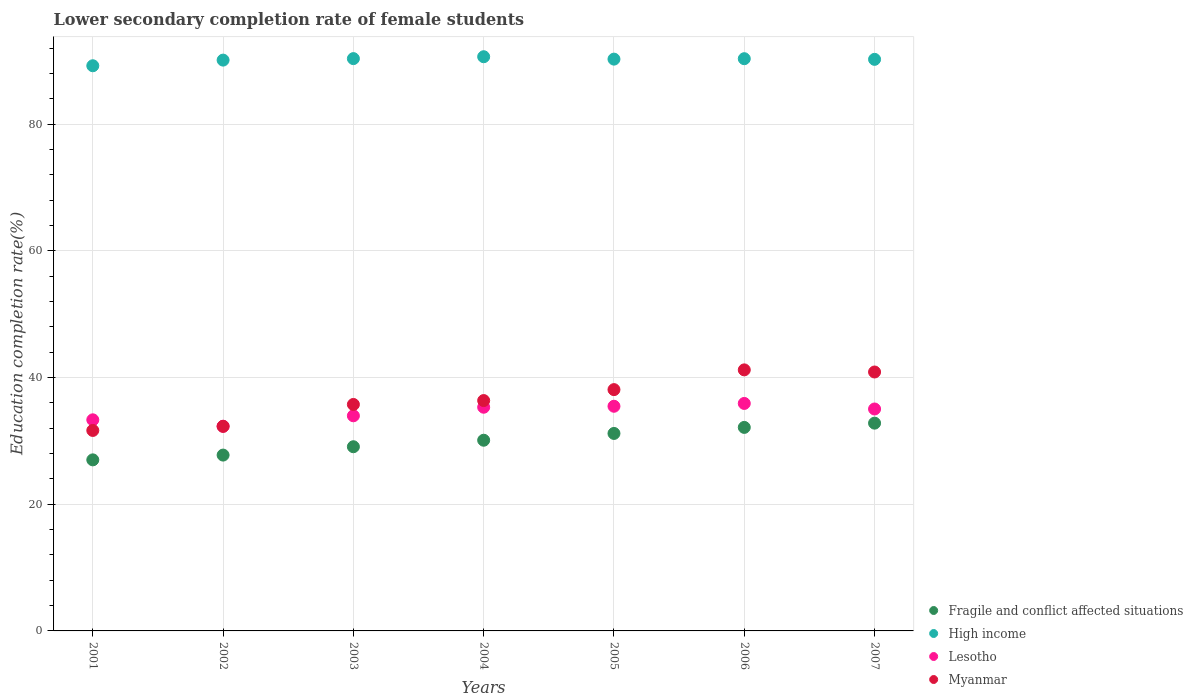How many different coloured dotlines are there?
Your answer should be very brief. 4. Is the number of dotlines equal to the number of legend labels?
Offer a terse response. Yes. What is the lower secondary completion rate of female students in High income in 2002?
Your response must be concise. 90.14. Across all years, what is the maximum lower secondary completion rate of female students in Myanmar?
Offer a very short reply. 41.22. Across all years, what is the minimum lower secondary completion rate of female students in Fragile and conflict affected situations?
Keep it short and to the point. 27.01. In which year was the lower secondary completion rate of female students in Lesotho maximum?
Provide a succinct answer. 2006. What is the total lower secondary completion rate of female students in Myanmar in the graph?
Offer a very short reply. 256.32. What is the difference between the lower secondary completion rate of female students in Fragile and conflict affected situations in 2001 and that in 2002?
Provide a short and direct response. -0.75. What is the difference between the lower secondary completion rate of female students in Fragile and conflict affected situations in 2004 and the lower secondary completion rate of female students in High income in 2005?
Your answer should be compact. -60.18. What is the average lower secondary completion rate of female students in Fragile and conflict affected situations per year?
Your response must be concise. 30.02. In the year 2005, what is the difference between the lower secondary completion rate of female students in High income and lower secondary completion rate of female students in Fragile and conflict affected situations?
Give a very brief answer. 59.11. In how many years, is the lower secondary completion rate of female students in Myanmar greater than 84 %?
Your response must be concise. 0. What is the ratio of the lower secondary completion rate of female students in Lesotho in 2001 to that in 2002?
Ensure brevity in your answer.  1.03. Is the difference between the lower secondary completion rate of female students in High income in 2003 and 2007 greater than the difference between the lower secondary completion rate of female students in Fragile and conflict affected situations in 2003 and 2007?
Make the answer very short. Yes. What is the difference between the highest and the second highest lower secondary completion rate of female students in High income?
Your answer should be compact. 0.3. What is the difference between the highest and the lowest lower secondary completion rate of female students in Myanmar?
Your answer should be very brief. 9.57. Is the sum of the lower secondary completion rate of female students in Myanmar in 2002 and 2003 greater than the maximum lower secondary completion rate of female students in Fragile and conflict affected situations across all years?
Offer a terse response. Yes. Does the lower secondary completion rate of female students in Myanmar monotonically increase over the years?
Provide a short and direct response. No. Is the lower secondary completion rate of female students in High income strictly greater than the lower secondary completion rate of female students in Fragile and conflict affected situations over the years?
Offer a very short reply. Yes. Is the lower secondary completion rate of female students in Myanmar strictly less than the lower secondary completion rate of female students in Fragile and conflict affected situations over the years?
Your answer should be very brief. No. How many dotlines are there?
Offer a very short reply. 4. How many years are there in the graph?
Provide a short and direct response. 7. Are the values on the major ticks of Y-axis written in scientific E-notation?
Make the answer very short. No. Does the graph contain any zero values?
Your response must be concise. No. Does the graph contain grids?
Give a very brief answer. Yes. How many legend labels are there?
Your answer should be very brief. 4. How are the legend labels stacked?
Your answer should be compact. Vertical. What is the title of the graph?
Give a very brief answer. Lower secondary completion rate of female students. Does "Kazakhstan" appear as one of the legend labels in the graph?
Ensure brevity in your answer.  No. What is the label or title of the X-axis?
Your response must be concise. Years. What is the label or title of the Y-axis?
Your answer should be compact. Education completion rate(%). What is the Education completion rate(%) of Fragile and conflict affected situations in 2001?
Make the answer very short. 27.01. What is the Education completion rate(%) in High income in 2001?
Your answer should be compact. 89.25. What is the Education completion rate(%) in Lesotho in 2001?
Your response must be concise. 33.34. What is the Education completion rate(%) in Myanmar in 2001?
Your answer should be compact. 31.66. What is the Education completion rate(%) of Fragile and conflict affected situations in 2002?
Provide a short and direct response. 27.77. What is the Education completion rate(%) of High income in 2002?
Your answer should be compact. 90.14. What is the Education completion rate(%) in Lesotho in 2002?
Your answer should be compact. 32.33. What is the Education completion rate(%) of Myanmar in 2002?
Your answer should be very brief. 32.3. What is the Education completion rate(%) of Fragile and conflict affected situations in 2003?
Your response must be concise. 29.09. What is the Education completion rate(%) in High income in 2003?
Your answer should be compact. 90.38. What is the Education completion rate(%) in Lesotho in 2003?
Provide a short and direct response. 33.97. What is the Education completion rate(%) in Myanmar in 2003?
Keep it short and to the point. 35.76. What is the Education completion rate(%) of Fragile and conflict affected situations in 2004?
Give a very brief answer. 30.11. What is the Education completion rate(%) of High income in 2004?
Keep it short and to the point. 90.67. What is the Education completion rate(%) of Lesotho in 2004?
Offer a very short reply. 35.32. What is the Education completion rate(%) in Myanmar in 2004?
Offer a very short reply. 36.38. What is the Education completion rate(%) of Fragile and conflict affected situations in 2005?
Give a very brief answer. 31.19. What is the Education completion rate(%) in High income in 2005?
Make the answer very short. 90.3. What is the Education completion rate(%) of Lesotho in 2005?
Your answer should be compact. 35.48. What is the Education completion rate(%) in Myanmar in 2005?
Your answer should be compact. 38.11. What is the Education completion rate(%) in Fragile and conflict affected situations in 2006?
Provide a short and direct response. 32.14. What is the Education completion rate(%) in High income in 2006?
Give a very brief answer. 90.36. What is the Education completion rate(%) in Lesotho in 2006?
Give a very brief answer. 35.92. What is the Education completion rate(%) of Myanmar in 2006?
Give a very brief answer. 41.22. What is the Education completion rate(%) of Fragile and conflict affected situations in 2007?
Ensure brevity in your answer.  32.81. What is the Education completion rate(%) of High income in 2007?
Your response must be concise. 90.26. What is the Education completion rate(%) of Lesotho in 2007?
Offer a very short reply. 35.05. What is the Education completion rate(%) of Myanmar in 2007?
Offer a terse response. 40.89. Across all years, what is the maximum Education completion rate(%) in Fragile and conflict affected situations?
Give a very brief answer. 32.81. Across all years, what is the maximum Education completion rate(%) of High income?
Offer a terse response. 90.67. Across all years, what is the maximum Education completion rate(%) in Lesotho?
Provide a succinct answer. 35.92. Across all years, what is the maximum Education completion rate(%) in Myanmar?
Keep it short and to the point. 41.22. Across all years, what is the minimum Education completion rate(%) of Fragile and conflict affected situations?
Your response must be concise. 27.01. Across all years, what is the minimum Education completion rate(%) in High income?
Keep it short and to the point. 89.25. Across all years, what is the minimum Education completion rate(%) in Lesotho?
Provide a succinct answer. 32.33. Across all years, what is the minimum Education completion rate(%) of Myanmar?
Ensure brevity in your answer.  31.66. What is the total Education completion rate(%) of Fragile and conflict affected situations in the graph?
Offer a terse response. 210.11. What is the total Education completion rate(%) of High income in the graph?
Keep it short and to the point. 631.36. What is the total Education completion rate(%) in Lesotho in the graph?
Give a very brief answer. 241.41. What is the total Education completion rate(%) in Myanmar in the graph?
Your response must be concise. 256.32. What is the difference between the Education completion rate(%) in Fragile and conflict affected situations in 2001 and that in 2002?
Provide a short and direct response. -0.75. What is the difference between the Education completion rate(%) in High income in 2001 and that in 2002?
Offer a very short reply. -0.89. What is the difference between the Education completion rate(%) of Lesotho in 2001 and that in 2002?
Offer a terse response. 1.01. What is the difference between the Education completion rate(%) of Myanmar in 2001 and that in 2002?
Offer a very short reply. -0.65. What is the difference between the Education completion rate(%) of Fragile and conflict affected situations in 2001 and that in 2003?
Offer a terse response. -2.07. What is the difference between the Education completion rate(%) in High income in 2001 and that in 2003?
Give a very brief answer. -1.13. What is the difference between the Education completion rate(%) of Lesotho in 2001 and that in 2003?
Offer a very short reply. -0.63. What is the difference between the Education completion rate(%) in Myanmar in 2001 and that in 2003?
Your response must be concise. -4.11. What is the difference between the Education completion rate(%) of Fragile and conflict affected situations in 2001 and that in 2004?
Make the answer very short. -3.1. What is the difference between the Education completion rate(%) of High income in 2001 and that in 2004?
Give a very brief answer. -1.43. What is the difference between the Education completion rate(%) in Lesotho in 2001 and that in 2004?
Provide a short and direct response. -1.99. What is the difference between the Education completion rate(%) of Myanmar in 2001 and that in 2004?
Offer a terse response. -4.72. What is the difference between the Education completion rate(%) of Fragile and conflict affected situations in 2001 and that in 2005?
Offer a very short reply. -4.17. What is the difference between the Education completion rate(%) in High income in 2001 and that in 2005?
Ensure brevity in your answer.  -1.05. What is the difference between the Education completion rate(%) of Lesotho in 2001 and that in 2005?
Give a very brief answer. -2.14. What is the difference between the Education completion rate(%) of Myanmar in 2001 and that in 2005?
Provide a succinct answer. -6.45. What is the difference between the Education completion rate(%) of Fragile and conflict affected situations in 2001 and that in 2006?
Provide a short and direct response. -5.13. What is the difference between the Education completion rate(%) in High income in 2001 and that in 2006?
Provide a succinct answer. -1.11. What is the difference between the Education completion rate(%) in Lesotho in 2001 and that in 2006?
Keep it short and to the point. -2.59. What is the difference between the Education completion rate(%) in Myanmar in 2001 and that in 2006?
Provide a short and direct response. -9.57. What is the difference between the Education completion rate(%) in Fragile and conflict affected situations in 2001 and that in 2007?
Keep it short and to the point. -5.8. What is the difference between the Education completion rate(%) in High income in 2001 and that in 2007?
Your response must be concise. -1.01. What is the difference between the Education completion rate(%) in Lesotho in 2001 and that in 2007?
Your response must be concise. -1.71. What is the difference between the Education completion rate(%) of Myanmar in 2001 and that in 2007?
Ensure brevity in your answer.  -9.23. What is the difference between the Education completion rate(%) in Fragile and conflict affected situations in 2002 and that in 2003?
Keep it short and to the point. -1.32. What is the difference between the Education completion rate(%) in High income in 2002 and that in 2003?
Offer a terse response. -0.24. What is the difference between the Education completion rate(%) in Lesotho in 2002 and that in 2003?
Provide a succinct answer. -1.64. What is the difference between the Education completion rate(%) of Myanmar in 2002 and that in 2003?
Provide a succinct answer. -3.46. What is the difference between the Education completion rate(%) in Fragile and conflict affected situations in 2002 and that in 2004?
Your response must be concise. -2.35. What is the difference between the Education completion rate(%) of High income in 2002 and that in 2004?
Give a very brief answer. -0.53. What is the difference between the Education completion rate(%) of Lesotho in 2002 and that in 2004?
Offer a very short reply. -3. What is the difference between the Education completion rate(%) of Myanmar in 2002 and that in 2004?
Offer a very short reply. -4.07. What is the difference between the Education completion rate(%) of Fragile and conflict affected situations in 2002 and that in 2005?
Offer a terse response. -3.42. What is the difference between the Education completion rate(%) of High income in 2002 and that in 2005?
Offer a terse response. -0.16. What is the difference between the Education completion rate(%) in Lesotho in 2002 and that in 2005?
Offer a very short reply. -3.15. What is the difference between the Education completion rate(%) of Myanmar in 2002 and that in 2005?
Make the answer very short. -5.8. What is the difference between the Education completion rate(%) of Fragile and conflict affected situations in 2002 and that in 2006?
Make the answer very short. -4.37. What is the difference between the Education completion rate(%) in High income in 2002 and that in 2006?
Your response must be concise. -0.22. What is the difference between the Education completion rate(%) in Lesotho in 2002 and that in 2006?
Ensure brevity in your answer.  -3.6. What is the difference between the Education completion rate(%) of Myanmar in 2002 and that in 2006?
Provide a short and direct response. -8.92. What is the difference between the Education completion rate(%) of Fragile and conflict affected situations in 2002 and that in 2007?
Your response must be concise. -5.04. What is the difference between the Education completion rate(%) of High income in 2002 and that in 2007?
Your response must be concise. -0.12. What is the difference between the Education completion rate(%) of Lesotho in 2002 and that in 2007?
Keep it short and to the point. -2.72. What is the difference between the Education completion rate(%) of Myanmar in 2002 and that in 2007?
Your answer should be very brief. -8.58. What is the difference between the Education completion rate(%) in Fragile and conflict affected situations in 2003 and that in 2004?
Provide a short and direct response. -1.03. What is the difference between the Education completion rate(%) in High income in 2003 and that in 2004?
Provide a short and direct response. -0.3. What is the difference between the Education completion rate(%) of Lesotho in 2003 and that in 2004?
Your answer should be compact. -1.35. What is the difference between the Education completion rate(%) of Myanmar in 2003 and that in 2004?
Your response must be concise. -0.61. What is the difference between the Education completion rate(%) of Fragile and conflict affected situations in 2003 and that in 2005?
Make the answer very short. -2.1. What is the difference between the Education completion rate(%) in High income in 2003 and that in 2005?
Offer a very short reply. 0.08. What is the difference between the Education completion rate(%) in Lesotho in 2003 and that in 2005?
Your answer should be compact. -1.51. What is the difference between the Education completion rate(%) in Myanmar in 2003 and that in 2005?
Offer a terse response. -2.34. What is the difference between the Education completion rate(%) in Fragile and conflict affected situations in 2003 and that in 2006?
Offer a very short reply. -3.05. What is the difference between the Education completion rate(%) in High income in 2003 and that in 2006?
Keep it short and to the point. 0.01. What is the difference between the Education completion rate(%) of Lesotho in 2003 and that in 2006?
Provide a short and direct response. -1.95. What is the difference between the Education completion rate(%) of Myanmar in 2003 and that in 2006?
Provide a succinct answer. -5.46. What is the difference between the Education completion rate(%) of Fragile and conflict affected situations in 2003 and that in 2007?
Offer a terse response. -3.72. What is the difference between the Education completion rate(%) of High income in 2003 and that in 2007?
Offer a terse response. 0.12. What is the difference between the Education completion rate(%) in Lesotho in 2003 and that in 2007?
Your answer should be very brief. -1.07. What is the difference between the Education completion rate(%) of Myanmar in 2003 and that in 2007?
Make the answer very short. -5.12. What is the difference between the Education completion rate(%) of Fragile and conflict affected situations in 2004 and that in 2005?
Ensure brevity in your answer.  -1.07. What is the difference between the Education completion rate(%) in High income in 2004 and that in 2005?
Offer a very short reply. 0.38. What is the difference between the Education completion rate(%) in Lesotho in 2004 and that in 2005?
Your answer should be very brief. -0.15. What is the difference between the Education completion rate(%) in Myanmar in 2004 and that in 2005?
Offer a terse response. -1.73. What is the difference between the Education completion rate(%) in Fragile and conflict affected situations in 2004 and that in 2006?
Provide a succinct answer. -2.03. What is the difference between the Education completion rate(%) of High income in 2004 and that in 2006?
Your answer should be compact. 0.31. What is the difference between the Education completion rate(%) of Lesotho in 2004 and that in 2006?
Provide a succinct answer. -0.6. What is the difference between the Education completion rate(%) in Myanmar in 2004 and that in 2006?
Provide a succinct answer. -4.85. What is the difference between the Education completion rate(%) of Fragile and conflict affected situations in 2004 and that in 2007?
Give a very brief answer. -2.7. What is the difference between the Education completion rate(%) in High income in 2004 and that in 2007?
Keep it short and to the point. 0.41. What is the difference between the Education completion rate(%) in Lesotho in 2004 and that in 2007?
Provide a succinct answer. 0.28. What is the difference between the Education completion rate(%) in Myanmar in 2004 and that in 2007?
Your answer should be compact. -4.51. What is the difference between the Education completion rate(%) in Fragile and conflict affected situations in 2005 and that in 2006?
Ensure brevity in your answer.  -0.95. What is the difference between the Education completion rate(%) in High income in 2005 and that in 2006?
Make the answer very short. -0.07. What is the difference between the Education completion rate(%) of Lesotho in 2005 and that in 2006?
Provide a succinct answer. -0.45. What is the difference between the Education completion rate(%) in Myanmar in 2005 and that in 2006?
Offer a terse response. -3.12. What is the difference between the Education completion rate(%) in Fragile and conflict affected situations in 2005 and that in 2007?
Ensure brevity in your answer.  -1.62. What is the difference between the Education completion rate(%) of High income in 2005 and that in 2007?
Your answer should be very brief. 0.03. What is the difference between the Education completion rate(%) of Lesotho in 2005 and that in 2007?
Your answer should be compact. 0.43. What is the difference between the Education completion rate(%) of Myanmar in 2005 and that in 2007?
Give a very brief answer. -2.78. What is the difference between the Education completion rate(%) of Fragile and conflict affected situations in 2006 and that in 2007?
Your response must be concise. -0.67. What is the difference between the Education completion rate(%) of High income in 2006 and that in 2007?
Offer a very short reply. 0.1. What is the difference between the Education completion rate(%) of Lesotho in 2006 and that in 2007?
Your response must be concise. 0.88. What is the difference between the Education completion rate(%) of Myanmar in 2006 and that in 2007?
Keep it short and to the point. 0.34. What is the difference between the Education completion rate(%) in Fragile and conflict affected situations in 2001 and the Education completion rate(%) in High income in 2002?
Give a very brief answer. -63.13. What is the difference between the Education completion rate(%) in Fragile and conflict affected situations in 2001 and the Education completion rate(%) in Lesotho in 2002?
Your answer should be very brief. -5.31. What is the difference between the Education completion rate(%) of Fragile and conflict affected situations in 2001 and the Education completion rate(%) of Myanmar in 2002?
Give a very brief answer. -5.29. What is the difference between the Education completion rate(%) in High income in 2001 and the Education completion rate(%) in Lesotho in 2002?
Ensure brevity in your answer.  56.92. What is the difference between the Education completion rate(%) of High income in 2001 and the Education completion rate(%) of Myanmar in 2002?
Make the answer very short. 56.95. What is the difference between the Education completion rate(%) in Lesotho in 2001 and the Education completion rate(%) in Myanmar in 2002?
Keep it short and to the point. 1.03. What is the difference between the Education completion rate(%) of Fragile and conflict affected situations in 2001 and the Education completion rate(%) of High income in 2003?
Offer a terse response. -63.36. What is the difference between the Education completion rate(%) in Fragile and conflict affected situations in 2001 and the Education completion rate(%) in Lesotho in 2003?
Offer a terse response. -6.96. What is the difference between the Education completion rate(%) in Fragile and conflict affected situations in 2001 and the Education completion rate(%) in Myanmar in 2003?
Make the answer very short. -8.75. What is the difference between the Education completion rate(%) in High income in 2001 and the Education completion rate(%) in Lesotho in 2003?
Make the answer very short. 55.28. What is the difference between the Education completion rate(%) in High income in 2001 and the Education completion rate(%) in Myanmar in 2003?
Offer a terse response. 53.49. What is the difference between the Education completion rate(%) in Lesotho in 2001 and the Education completion rate(%) in Myanmar in 2003?
Your answer should be compact. -2.43. What is the difference between the Education completion rate(%) in Fragile and conflict affected situations in 2001 and the Education completion rate(%) in High income in 2004?
Provide a succinct answer. -63.66. What is the difference between the Education completion rate(%) in Fragile and conflict affected situations in 2001 and the Education completion rate(%) in Lesotho in 2004?
Keep it short and to the point. -8.31. What is the difference between the Education completion rate(%) in Fragile and conflict affected situations in 2001 and the Education completion rate(%) in Myanmar in 2004?
Make the answer very short. -9.36. What is the difference between the Education completion rate(%) of High income in 2001 and the Education completion rate(%) of Lesotho in 2004?
Your answer should be compact. 53.93. What is the difference between the Education completion rate(%) in High income in 2001 and the Education completion rate(%) in Myanmar in 2004?
Make the answer very short. 52.87. What is the difference between the Education completion rate(%) in Lesotho in 2001 and the Education completion rate(%) in Myanmar in 2004?
Provide a succinct answer. -3.04. What is the difference between the Education completion rate(%) of Fragile and conflict affected situations in 2001 and the Education completion rate(%) of High income in 2005?
Give a very brief answer. -63.28. What is the difference between the Education completion rate(%) in Fragile and conflict affected situations in 2001 and the Education completion rate(%) in Lesotho in 2005?
Provide a short and direct response. -8.46. What is the difference between the Education completion rate(%) of Fragile and conflict affected situations in 2001 and the Education completion rate(%) of Myanmar in 2005?
Provide a succinct answer. -11.09. What is the difference between the Education completion rate(%) of High income in 2001 and the Education completion rate(%) of Lesotho in 2005?
Offer a very short reply. 53.77. What is the difference between the Education completion rate(%) in High income in 2001 and the Education completion rate(%) in Myanmar in 2005?
Make the answer very short. 51.14. What is the difference between the Education completion rate(%) in Lesotho in 2001 and the Education completion rate(%) in Myanmar in 2005?
Ensure brevity in your answer.  -4.77. What is the difference between the Education completion rate(%) of Fragile and conflict affected situations in 2001 and the Education completion rate(%) of High income in 2006?
Ensure brevity in your answer.  -63.35. What is the difference between the Education completion rate(%) in Fragile and conflict affected situations in 2001 and the Education completion rate(%) in Lesotho in 2006?
Offer a terse response. -8.91. What is the difference between the Education completion rate(%) of Fragile and conflict affected situations in 2001 and the Education completion rate(%) of Myanmar in 2006?
Give a very brief answer. -14.21. What is the difference between the Education completion rate(%) of High income in 2001 and the Education completion rate(%) of Lesotho in 2006?
Ensure brevity in your answer.  53.33. What is the difference between the Education completion rate(%) in High income in 2001 and the Education completion rate(%) in Myanmar in 2006?
Give a very brief answer. 48.03. What is the difference between the Education completion rate(%) in Lesotho in 2001 and the Education completion rate(%) in Myanmar in 2006?
Your answer should be very brief. -7.89. What is the difference between the Education completion rate(%) of Fragile and conflict affected situations in 2001 and the Education completion rate(%) of High income in 2007?
Your answer should be very brief. -63.25. What is the difference between the Education completion rate(%) in Fragile and conflict affected situations in 2001 and the Education completion rate(%) in Lesotho in 2007?
Ensure brevity in your answer.  -8.03. What is the difference between the Education completion rate(%) of Fragile and conflict affected situations in 2001 and the Education completion rate(%) of Myanmar in 2007?
Your answer should be compact. -13.87. What is the difference between the Education completion rate(%) of High income in 2001 and the Education completion rate(%) of Lesotho in 2007?
Offer a very short reply. 54.2. What is the difference between the Education completion rate(%) of High income in 2001 and the Education completion rate(%) of Myanmar in 2007?
Your answer should be very brief. 48.36. What is the difference between the Education completion rate(%) of Lesotho in 2001 and the Education completion rate(%) of Myanmar in 2007?
Make the answer very short. -7.55. What is the difference between the Education completion rate(%) of Fragile and conflict affected situations in 2002 and the Education completion rate(%) of High income in 2003?
Your answer should be compact. -62.61. What is the difference between the Education completion rate(%) in Fragile and conflict affected situations in 2002 and the Education completion rate(%) in Lesotho in 2003?
Offer a terse response. -6.2. What is the difference between the Education completion rate(%) of Fragile and conflict affected situations in 2002 and the Education completion rate(%) of Myanmar in 2003?
Your response must be concise. -8. What is the difference between the Education completion rate(%) of High income in 2002 and the Education completion rate(%) of Lesotho in 2003?
Your response must be concise. 56.17. What is the difference between the Education completion rate(%) in High income in 2002 and the Education completion rate(%) in Myanmar in 2003?
Make the answer very short. 54.38. What is the difference between the Education completion rate(%) of Lesotho in 2002 and the Education completion rate(%) of Myanmar in 2003?
Provide a succinct answer. -3.44. What is the difference between the Education completion rate(%) of Fragile and conflict affected situations in 2002 and the Education completion rate(%) of High income in 2004?
Offer a terse response. -62.91. What is the difference between the Education completion rate(%) of Fragile and conflict affected situations in 2002 and the Education completion rate(%) of Lesotho in 2004?
Your answer should be very brief. -7.56. What is the difference between the Education completion rate(%) of Fragile and conflict affected situations in 2002 and the Education completion rate(%) of Myanmar in 2004?
Keep it short and to the point. -8.61. What is the difference between the Education completion rate(%) of High income in 2002 and the Education completion rate(%) of Lesotho in 2004?
Ensure brevity in your answer.  54.82. What is the difference between the Education completion rate(%) in High income in 2002 and the Education completion rate(%) in Myanmar in 2004?
Offer a very short reply. 53.76. What is the difference between the Education completion rate(%) of Lesotho in 2002 and the Education completion rate(%) of Myanmar in 2004?
Your answer should be compact. -4.05. What is the difference between the Education completion rate(%) of Fragile and conflict affected situations in 2002 and the Education completion rate(%) of High income in 2005?
Offer a very short reply. -62.53. What is the difference between the Education completion rate(%) of Fragile and conflict affected situations in 2002 and the Education completion rate(%) of Lesotho in 2005?
Provide a succinct answer. -7.71. What is the difference between the Education completion rate(%) of Fragile and conflict affected situations in 2002 and the Education completion rate(%) of Myanmar in 2005?
Provide a short and direct response. -10.34. What is the difference between the Education completion rate(%) in High income in 2002 and the Education completion rate(%) in Lesotho in 2005?
Provide a short and direct response. 54.66. What is the difference between the Education completion rate(%) of High income in 2002 and the Education completion rate(%) of Myanmar in 2005?
Keep it short and to the point. 52.04. What is the difference between the Education completion rate(%) of Lesotho in 2002 and the Education completion rate(%) of Myanmar in 2005?
Your answer should be very brief. -5.78. What is the difference between the Education completion rate(%) of Fragile and conflict affected situations in 2002 and the Education completion rate(%) of High income in 2006?
Give a very brief answer. -62.6. What is the difference between the Education completion rate(%) in Fragile and conflict affected situations in 2002 and the Education completion rate(%) in Lesotho in 2006?
Keep it short and to the point. -8.16. What is the difference between the Education completion rate(%) in Fragile and conflict affected situations in 2002 and the Education completion rate(%) in Myanmar in 2006?
Give a very brief answer. -13.46. What is the difference between the Education completion rate(%) in High income in 2002 and the Education completion rate(%) in Lesotho in 2006?
Keep it short and to the point. 54.22. What is the difference between the Education completion rate(%) in High income in 2002 and the Education completion rate(%) in Myanmar in 2006?
Offer a terse response. 48.92. What is the difference between the Education completion rate(%) of Lesotho in 2002 and the Education completion rate(%) of Myanmar in 2006?
Ensure brevity in your answer.  -8.9. What is the difference between the Education completion rate(%) of Fragile and conflict affected situations in 2002 and the Education completion rate(%) of High income in 2007?
Your response must be concise. -62.49. What is the difference between the Education completion rate(%) in Fragile and conflict affected situations in 2002 and the Education completion rate(%) in Lesotho in 2007?
Your answer should be very brief. -7.28. What is the difference between the Education completion rate(%) in Fragile and conflict affected situations in 2002 and the Education completion rate(%) in Myanmar in 2007?
Give a very brief answer. -13.12. What is the difference between the Education completion rate(%) of High income in 2002 and the Education completion rate(%) of Lesotho in 2007?
Keep it short and to the point. 55.1. What is the difference between the Education completion rate(%) in High income in 2002 and the Education completion rate(%) in Myanmar in 2007?
Make the answer very short. 49.25. What is the difference between the Education completion rate(%) of Lesotho in 2002 and the Education completion rate(%) of Myanmar in 2007?
Keep it short and to the point. -8.56. What is the difference between the Education completion rate(%) in Fragile and conflict affected situations in 2003 and the Education completion rate(%) in High income in 2004?
Offer a very short reply. -61.59. What is the difference between the Education completion rate(%) of Fragile and conflict affected situations in 2003 and the Education completion rate(%) of Lesotho in 2004?
Provide a succinct answer. -6.24. What is the difference between the Education completion rate(%) in Fragile and conflict affected situations in 2003 and the Education completion rate(%) in Myanmar in 2004?
Your answer should be compact. -7.29. What is the difference between the Education completion rate(%) in High income in 2003 and the Education completion rate(%) in Lesotho in 2004?
Offer a terse response. 55.05. What is the difference between the Education completion rate(%) in High income in 2003 and the Education completion rate(%) in Myanmar in 2004?
Offer a very short reply. 54. What is the difference between the Education completion rate(%) in Lesotho in 2003 and the Education completion rate(%) in Myanmar in 2004?
Offer a terse response. -2.41. What is the difference between the Education completion rate(%) of Fragile and conflict affected situations in 2003 and the Education completion rate(%) of High income in 2005?
Your answer should be compact. -61.21. What is the difference between the Education completion rate(%) in Fragile and conflict affected situations in 2003 and the Education completion rate(%) in Lesotho in 2005?
Your response must be concise. -6.39. What is the difference between the Education completion rate(%) of Fragile and conflict affected situations in 2003 and the Education completion rate(%) of Myanmar in 2005?
Your answer should be compact. -9.02. What is the difference between the Education completion rate(%) of High income in 2003 and the Education completion rate(%) of Lesotho in 2005?
Your answer should be very brief. 54.9. What is the difference between the Education completion rate(%) in High income in 2003 and the Education completion rate(%) in Myanmar in 2005?
Your answer should be very brief. 52.27. What is the difference between the Education completion rate(%) in Lesotho in 2003 and the Education completion rate(%) in Myanmar in 2005?
Offer a terse response. -4.13. What is the difference between the Education completion rate(%) in Fragile and conflict affected situations in 2003 and the Education completion rate(%) in High income in 2006?
Your answer should be compact. -61.28. What is the difference between the Education completion rate(%) of Fragile and conflict affected situations in 2003 and the Education completion rate(%) of Lesotho in 2006?
Keep it short and to the point. -6.84. What is the difference between the Education completion rate(%) of Fragile and conflict affected situations in 2003 and the Education completion rate(%) of Myanmar in 2006?
Make the answer very short. -12.14. What is the difference between the Education completion rate(%) in High income in 2003 and the Education completion rate(%) in Lesotho in 2006?
Offer a very short reply. 54.45. What is the difference between the Education completion rate(%) of High income in 2003 and the Education completion rate(%) of Myanmar in 2006?
Your answer should be very brief. 49.15. What is the difference between the Education completion rate(%) in Lesotho in 2003 and the Education completion rate(%) in Myanmar in 2006?
Make the answer very short. -7.25. What is the difference between the Education completion rate(%) in Fragile and conflict affected situations in 2003 and the Education completion rate(%) in High income in 2007?
Offer a terse response. -61.18. What is the difference between the Education completion rate(%) in Fragile and conflict affected situations in 2003 and the Education completion rate(%) in Lesotho in 2007?
Give a very brief answer. -5.96. What is the difference between the Education completion rate(%) in Fragile and conflict affected situations in 2003 and the Education completion rate(%) in Myanmar in 2007?
Offer a terse response. -11.8. What is the difference between the Education completion rate(%) of High income in 2003 and the Education completion rate(%) of Lesotho in 2007?
Ensure brevity in your answer.  55.33. What is the difference between the Education completion rate(%) of High income in 2003 and the Education completion rate(%) of Myanmar in 2007?
Make the answer very short. 49.49. What is the difference between the Education completion rate(%) of Lesotho in 2003 and the Education completion rate(%) of Myanmar in 2007?
Your answer should be compact. -6.92. What is the difference between the Education completion rate(%) in Fragile and conflict affected situations in 2004 and the Education completion rate(%) in High income in 2005?
Provide a succinct answer. -60.18. What is the difference between the Education completion rate(%) of Fragile and conflict affected situations in 2004 and the Education completion rate(%) of Lesotho in 2005?
Your answer should be compact. -5.37. What is the difference between the Education completion rate(%) of Fragile and conflict affected situations in 2004 and the Education completion rate(%) of Myanmar in 2005?
Keep it short and to the point. -7.99. What is the difference between the Education completion rate(%) of High income in 2004 and the Education completion rate(%) of Lesotho in 2005?
Provide a succinct answer. 55.2. What is the difference between the Education completion rate(%) in High income in 2004 and the Education completion rate(%) in Myanmar in 2005?
Ensure brevity in your answer.  52.57. What is the difference between the Education completion rate(%) of Lesotho in 2004 and the Education completion rate(%) of Myanmar in 2005?
Keep it short and to the point. -2.78. What is the difference between the Education completion rate(%) in Fragile and conflict affected situations in 2004 and the Education completion rate(%) in High income in 2006?
Keep it short and to the point. -60.25. What is the difference between the Education completion rate(%) of Fragile and conflict affected situations in 2004 and the Education completion rate(%) of Lesotho in 2006?
Ensure brevity in your answer.  -5.81. What is the difference between the Education completion rate(%) of Fragile and conflict affected situations in 2004 and the Education completion rate(%) of Myanmar in 2006?
Provide a succinct answer. -11.11. What is the difference between the Education completion rate(%) in High income in 2004 and the Education completion rate(%) in Lesotho in 2006?
Make the answer very short. 54.75. What is the difference between the Education completion rate(%) of High income in 2004 and the Education completion rate(%) of Myanmar in 2006?
Your answer should be very brief. 49.45. What is the difference between the Education completion rate(%) in Fragile and conflict affected situations in 2004 and the Education completion rate(%) in High income in 2007?
Your answer should be compact. -60.15. What is the difference between the Education completion rate(%) of Fragile and conflict affected situations in 2004 and the Education completion rate(%) of Lesotho in 2007?
Provide a succinct answer. -4.93. What is the difference between the Education completion rate(%) in Fragile and conflict affected situations in 2004 and the Education completion rate(%) in Myanmar in 2007?
Provide a short and direct response. -10.78. What is the difference between the Education completion rate(%) in High income in 2004 and the Education completion rate(%) in Lesotho in 2007?
Offer a terse response. 55.63. What is the difference between the Education completion rate(%) in High income in 2004 and the Education completion rate(%) in Myanmar in 2007?
Make the answer very short. 49.79. What is the difference between the Education completion rate(%) of Lesotho in 2004 and the Education completion rate(%) of Myanmar in 2007?
Your answer should be compact. -5.56. What is the difference between the Education completion rate(%) in Fragile and conflict affected situations in 2005 and the Education completion rate(%) in High income in 2006?
Make the answer very short. -59.18. What is the difference between the Education completion rate(%) in Fragile and conflict affected situations in 2005 and the Education completion rate(%) in Lesotho in 2006?
Your response must be concise. -4.74. What is the difference between the Education completion rate(%) of Fragile and conflict affected situations in 2005 and the Education completion rate(%) of Myanmar in 2006?
Keep it short and to the point. -10.04. What is the difference between the Education completion rate(%) of High income in 2005 and the Education completion rate(%) of Lesotho in 2006?
Ensure brevity in your answer.  54.37. What is the difference between the Education completion rate(%) of High income in 2005 and the Education completion rate(%) of Myanmar in 2006?
Offer a very short reply. 49.07. What is the difference between the Education completion rate(%) of Lesotho in 2005 and the Education completion rate(%) of Myanmar in 2006?
Keep it short and to the point. -5.75. What is the difference between the Education completion rate(%) of Fragile and conflict affected situations in 2005 and the Education completion rate(%) of High income in 2007?
Your answer should be very brief. -59.08. What is the difference between the Education completion rate(%) of Fragile and conflict affected situations in 2005 and the Education completion rate(%) of Lesotho in 2007?
Give a very brief answer. -3.86. What is the difference between the Education completion rate(%) in Fragile and conflict affected situations in 2005 and the Education completion rate(%) in Myanmar in 2007?
Make the answer very short. -9.7. What is the difference between the Education completion rate(%) in High income in 2005 and the Education completion rate(%) in Lesotho in 2007?
Provide a short and direct response. 55.25. What is the difference between the Education completion rate(%) in High income in 2005 and the Education completion rate(%) in Myanmar in 2007?
Make the answer very short. 49.41. What is the difference between the Education completion rate(%) of Lesotho in 2005 and the Education completion rate(%) of Myanmar in 2007?
Ensure brevity in your answer.  -5.41. What is the difference between the Education completion rate(%) of Fragile and conflict affected situations in 2006 and the Education completion rate(%) of High income in 2007?
Keep it short and to the point. -58.12. What is the difference between the Education completion rate(%) in Fragile and conflict affected situations in 2006 and the Education completion rate(%) in Lesotho in 2007?
Ensure brevity in your answer.  -2.91. What is the difference between the Education completion rate(%) of Fragile and conflict affected situations in 2006 and the Education completion rate(%) of Myanmar in 2007?
Offer a terse response. -8.75. What is the difference between the Education completion rate(%) of High income in 2006 and the Education completion rate(%) of Lesotho in 2007?
Make the answer very short. 55.32. What is the difference between the Education completion rate(%) in High income in 2006 and the Education completion rate(%) in Myanmar in 2007?
Provide a short and direct response. 49.48. What is the difference between the Education completion rate(%) in Lesotho in 2006 and the Education completion rate(%) in Myanmar in 2007?
Ensure brevity in your answer.  -4.96. What is the average Education completion rate(%) of Fragile and conflict affected situations per year?
Your answer should be compact. 30.02. What is the average Education completion rate(%) of High income per year?
Provide a short and direct response. 90.19. What is the average Education completion rate(%) of Lesotho per year?
Make the answer very short. 34.49. What is the average Education completion rate(%) of Myanmar per year?
Offer a terse response. 36.62. In the year 2001, what is the difference between the Education completion rate(%) of Fragile and conflict affected situations and Education completion rate(%) of High income?
Your answer should be compact. -62.24. In the year 2001, what is the difference between the Education completion rate(%) of Fragile and conflict affected situations and Education completion rate(%) of Lesotho?
Your answer should be very brief. -6.32. In the year 2001, what is the difference between the Education completion rate(%) of Fragile and conflict affected situations and Education completion rate(%) of Myanmar?
Ensure brevity in your answer.  -4.64. In the year 2001, what is the difference between the Education completion rate(%) of High income and Education completion rate(%) of Lesotho?
Provide a short and direct response. 55.91. In the year 2001, what is the difference between the Education completion rate(%) of High income and Education completion rate(%) of Myanmar?
Your answer should be very brief. 57.59. In the year 2001, what is the difference between the Education completion rate(%) of Lesotho and Education completion rate(%) of Myanmar?
Offer a terse response. 1.68. In the year 2002, what is the difference between the Education completion rate(%) of Fragile and conflict affected situations and Education completion rate(%) of High income?
Give a very brief answer. -62.37. In the year 2002, what is the difference between the Education completion rate(%) of Fragile and conflict affected situations and Education completion rate(%) of Lesotho?
Make the answer very short. -4.56. In the year 2002, what is the difference between the Education completion rate(%) of Fragile and conflict affected situations and Education completion rate(%) of Myanmar?
Your response must be concise. -4.54. In the year 2002, what is the difference between the Education completion rate(%) in High income and Education completion rate(%) in Lesotho?
Make the answer very short. 57.81. In the year 2002, what is the difference between the Education completion rate(%) of High income and Education completion rate(%) of Myanmar?
Your answer should be very brief. 57.84. In the year 2002, what is the difference between the Education completion rate(%) of Lesotho and Education completion rate(%) of Myanmar?
Provide a short and direct response. 0.02. In the year 2003, what is the difference between the Education completion rate(%) in Fragile and conflict affected situations and Education completion rate(%) in High income?
Offer a very short reply. -61.29. In the year 2003, what is the difference between the Education completion rate(%) in Fragile and conflict affected situations and Education completion rate(%) in Lesotho?
Offer a very short reply. -4.89. In the year 2003, what is the difference between the Education completion rate(%) in Fragile and conflict affected situations and Education completion rate(%) in Myanmar?
Your response must be concise. -6.68. In the year 2003, what is the difference between the Education completion rate(%) in High income and Education completion rate(%) in Lesotho?
Keep it short and to the point. 56.41. In the year 2003, what is the difference between the Education completion rate(%) of High income and Education completion rate(%) of Myanmar?
Offer a very short reply. 54.61. In the year 2003, what is the difference between the Education completion rate(%) in Lesotho and Education completion rate(%) in Myanmar?
Provide a short and direct response. -1.79. In the year 2004, what is the difference between the Education completion rate(%) in Fragile and conflict affected situations and Education completion rate(%) in High income?
Your answer should be compact. -60.56. In the year 2004, what is the difference between the Education completion rate(%) in Fragile and conflict affected situations and Education completion rate(%) in Lesotho?
Ensure brevity in your answer.  -5.21. In the year 2004, what is the difference between the Education completion rate(%) in Fragile and conflict affected situations and Education completion rate(%) in Myanmar?
Ensure brevity in your answer.  -6.26. In the year 2004, what is the difference between the Education completion rate(%) in High income and Education completion rate(%) in Lesotho?
Give a very brief answer. 55.35. In the year 2004, what is the difference between the Education completion rate(%) of High income and Education completion rate(%) of Myanmar?
Offer a very short reply. 54.3. In the year 2004, what is the difference between the Education completion rate(%) of Lesotho and Education completion rate(%) of Myanmar?
Your answer should be compact. -1.05. In the year 2005, what is the difference between the Education completion rate(%) in Fragile and conflict affected situations and Education completion rate(%) in High income?
Provide a short and direct response. -59.11. In the year 2005, what is the difference between the Education completion rate(%) of Fragile and conflict affected situations and Education completion rate(%) of Lesotho?
Ensure brevity in your answer.  -4.29. In the year 2005, what is the difference between the Education completion rate(%) of Fragile and conflict affected situations and Education completion rate(%) of Myanmar?
Ensure brevity in your answer.  -6.92. In the year 2005, what is the difference between the Education completion rate(%) in High income and Education completion rate(%) in Lesotho?
Provide a succinct answer. 54.82. In the year 2005, what is the difference between the Education completion rate(%) of High income and Education completion rate(%) of Myanmar?
Ensure brevity in your answer.  52.19. In the year 2005, what is the difference between the Education completion rate(%) in Lesotho and Education completion rate(%) in Myanmar?
Your answer should be very brief. -2.63. In the year 2006, what is the difference between the Education completion rate(%) in Fragile and conflict affected situations and Education completion rate(%) in High income?
Offer a very short reply. -58.22. In the year 2006, what is the difference between the Education completion rate(%) of Fragile and conflict affected situations and Education completion rate(%) of Lesotho?
Offer a terse response. -3.78. In the year 2006, what is the difference between the Education completion rate(%) in Fragile and conflict affected situations and Education completion rate(%) in Myanmar?
Provide a succinct answer. -9.09. In the year 2006, what is the difference between the Education completion rate(%) of High income and Education completion rate(%) of Lesotho?
Provide a succinct answer. 54.44. In the year 2006, what is the difference between the Education completion rate(%) in High income and Education completion rate(%) in Myanmar?
Your answer should be compact. 49.14. In the year 2006, what is the difference between the Education completion rate(%) of Lesotho and Education completion rate(%) of Myanmar?
Make the answer very short. -5.3. In the year 2007, what is the difference between the Education completion rate(%) in Fragile and conflict affected situations and Education completion rate(%) in High income?
Provide a succinct answer. -57.45. In the year 2007, what is the difference between the Education completion rate(%) in Fragile and conflict affected situations and Education completion rate(%) in Lesotho?
Your response must be concise. -2.24. In the year 2007, what is the difference between the Education completion rate(%) in Fragile and conflict affected situations and Education completion rate(%) in Myanmar?
Give a very brief answer. -8.08. In the year 2007, what is the difference between the Education completion rate(%) of High income and Education completion rate(%) of Lesotho?
Keep it short and to the point. 55.22. In the year 2007, what is the difference between the Education completion rate(%) in High income and Education completion rate(%) in Myanmar?
Your answer should be very brief. 49.37. In the year 2007, what is the difference between the Education completion rate(%) of Lesotho and Education completion rate(%) of Myanmar?
Your response must be concise. -5.84. What is the ratio of the Education completion rate(%) in Fragile and conflict affected situations in 2001 to that in 2002?
Provide a succinct answer. 0.97. What is the ratio of the Education completion rate(%) in High income in 2001 to that in 2002?
Provide a short and direct response. 0.99. What is the ratio of the Education completion rate(%) in Lesotho in 2001 to that in 2002?
Give a very brief answer. 1.03. What is the ratio of the Education completion rate(%) of Myanmar in 2001 to that in 2002?
Offer a terse response. 0.98. What is the ratio of the Education completion rate(%) in Fragile and conflict affected situations in 2001 to that in 2003?
Offer a terse response. 0.93. What is the ratio of the Education completion rate(%) of High income in 2001 to that in 2003?
Your response must be concise. 0.99. What is the ratio of the Education completion rate(%) in Lesotho in 2001 to that in 2003?
Ensure brevity in your answer.  0.98. What is the ratio of the Education completion rate(%) in Myanmar in 2001 to that in 2003?
Make the answer very short. 0.89. What is the ratio of the Education completion rate(%) in Fragile and conflict affected situations in 2001 to that in 2004?
Offer a terse response. 0.9. What is the ratio of the Education completion rate(%) of High income in 2001 to that in 2004?
Provide a short and direct response. 0.98. What is the ratio of the Education completion rate(%) of Lesotho in 2001 to that in 2004?
Provide a short and direct response. 0.94. What is the ratio of the Education completion rate(%) of Myanmar in 2001 to that in 2004?
Provide a short and direct response. 0.87. What is the ratio of the Education completion rate(%) in Fragile and conflict affected situations in 2001 to that in 2005?
Keep it short and to the point. 0.87. What is the ratio of the Education completion rate(%) of High income in 2001 to that in 2005?
Provide a succinct answer. 0.99. What is the ratio of the Education completion rate(%) of Lesotho in 2001 to that in 2005?
Give a very brief answer. 0.94. What is the ratio of the Education completion rate(%) of Myanmar in 2001 to that in 2005?
Provide a short and direct response. 0.83. What is the ratio of the Education completion rate(%) in Fragile and conflict affected situations in 2001 to that in 2006?
Provide a succinct answer. 0.84. What is the ratio of the Education completion rate(%) of Lesotho in 2001 to that in 2006?
Offer a very short reply. 0.93. What is the ratio of the Education completion rate(%) of Myanmar in 2001 to that in 2006?
Your answer should be compact. 0.77. What is the ratio of the Education completion rate(%) in Fragile and conflict affected situations in 2001 to that in 2007?
Provide a succinct answer. 0.82. What is the ratio of the Education completion rate(%) of High income in 2001 to that in 2007?
Your answer should be very brief. 0.99. What is the ratio of the Education completion rate(%) in Lesotho in 2001 to that in 2007?
Provide a succinct answer. 0.95. What is the ratio of the Education completion rate(%) of Myanmar in 2001 to that in 2007?
Your answer should be compact. 0.77. What is the ratio of the Education completion rate(%) of Fragile and conflict affected situations in 2002 to that in 2003?
Offer a very short reply. 0.95. What is the ratio of the Education completion rate(%) of High income in 2002 to that in 2003?
Your response must be concise. 1. What is the ratio of the Education completion rate(%) in Lesotho in 2002 to that in 2003?
Provide a short and direct response. 0.95. What is the ratio of the Education completion rate(%) of Myanmar in 2002 to that in 2003?
Your response must be concise. 0.9. What is the ratio of the Education completion rate(%) in Fragile and conflict affected situations in 2002 to that in 2004?
Offer a very short reply. 0.92. What is the ratio of the Education completion rate(%) in Lesotho in 2002 to that in 2004?
Offer a very short reply. 0.92. What is the ratio of the Education completion rate(%) of Myanmar in 2002 to that in 2004?
Provide a succinct answer. 0.89. What is the ratio of the Education completion rate(%) of Fragile and conflict affected situations in 2002 to that in 2005?
Your answer should be very brief. 0.89. What is the ratio of the Education completion rate(%) of High income in 2002 to that in 2005?
Offer a very short reply. 1. What is the ratio of the Education completion rate(%) in Lesotho in 2002 to that in 2005?
Provide a succinct answer. 0.91. What is the ratio of the Education completion rate(%) of Myanmar in 2002 to that in 2005?
Give a very brief answer. 0.85. What is the ratio of the Education completion rate(%) in Fragile and conflict affected situations in 2002 to that in 2006?
Your answer should be very brief. 0.86. What is the ratio of the Education completion rate(%) of High income in 2002 to that in 2006?
Your answer should be very brief. 1. What is the ratio of the Education completion rate(%) of Lesotho in 2002 to that in 2006?
Your response must be concise. 0.9. What is the ratio of the Education completion rate(%) in Myanmar in 2002 to that in 2006?
Give a very brief answer. 0.78. What is the ratio of the Education completion rate(%) in Fragile and conflict affected situations in 2002 to that in 2007?
Keep it short and to the point. 0.85. What is the ratio of the Education completion rate(%) of High income in 2002 to that in 2007?
Ensure brevity in your answer.  1. What is the ratio of the Education completion rate(%) of Lesotho in 2002 to that in 2007?
Provide a succinct answer. 0.92. What is the ratio of the Education completion rate(%) in Myanmar in 2002 to that in 2007?
Your answer should be very brief. 0.79. What is the ratio of the Education completion rate(%) of Fragile and conflict affected situations in 2003 to that in 2004?
Your response must be concise. 0.97. What is the ratio of the Education completion rate(%) of Lesotho in 2003 to that in 2004?
Your answer should be very brief. 0.96. What is the ratio of the Education completion rate(%) of Myanmar in 2003 to that in 2004?
Your answer should be very brief. 0.98. What is the ratio of the Education completion rate(%) of Fragile and conflict affected situations in 2003 to that in 2005?
Ensure brevity in your answer.  0.93. What is the ratio of the Education completion rate(%) of Lesotho in 2003 to that in 2005?
Give a very brief answer. 0.96. What is the ratio of the Education completion rate(%) in Myanmar in 2003 to that in 2005?
Offer a very short reply. 0.94. What is the ratio of the Education completion rate(%) of Fragile and conflict affected situations in 2003 to that in 2006?
Offer a terse response. 0.91. What is the ratio of the Education completion rate(%) in High income in 2003 to that in 2006?
Ensure brevity in your answer.  1. What is the ratio of the Education completion rate(%) in Lesotho in 2003 to that in 2006?
Your response must be concise. 0.95. What is the ratio of the Education completion rate(%) in Myanmar in 2003 to that in 2006?
Offer a terse response. 0.87. What is the ratio of the Education completion rate(%) in Fragile and conflict affected situations in 2003 to that in 2007?
Ensure brevity in your answer.  0.89. What is the ratio of the Education completion rate(%) of Lesotho in 2003 to that in 2007?
Make the answer very short. 0.97. What is the ratio of the Education completion rate(%) in Myanmar in 2003 to that in 2007?
Ensure brevity in your answer.  0.87. What is the ratio of the Education completion rate(%) of Fragile and conflict affected situations in 2004 to that in 2005?
Make the answer very short. 0.97. What is the ratio of the Education completion rate(%) in High income in 2004 to that in 2005?
Provide a succinct answer. 1. What is the ratio of the Education completion rate(%) in Lesotho in 2004 to that in 2005?
Offer a terse response. 1. What is the ratio of the Education completion rate(%) of Myanmar in 2004 to that in 2005?
Make the answer very short. 0.95. What is the ratio of the Education completion rate(%) of Fragile and conflict affected situations in 2004 to that in 2006?
Give a very brief answer. 0.94. What is the ratio of the Education completion rate(%) in Lesotho in 2004 to that in 2006?
Provide a short and direct response. 0.98. What is the ratio of the Education completion rate(%) of Myanmar in 2004 to that in 2006?
Make the answer very short. 0.88. What is the ratio of the Education completion rate(%) of Fragile and conflict affected situations in 2004 to that in 2007?
Provide a short and direct response. 0.92. What is the ratio of the Education completion rate(%) in High income in 2004 to that in 2007?
Your answer should be very brief. 1. What is the ratio of the Education completion rate(%) in Lesotho in 2004 to that in 2007?
Your answer should be compact. 1.01. What is the ratio of the Education completion rate(%) in Myanmar in 2004 to that in 2007?
Give a very brief answer. 0.89. What is the ratio of the Education completion rate(%) of Fragile and conflict affected situations in 2005 to that in 2006?
Provide a short and direct response. 0.97. What is the ratio of the Education completion rate(%) of High income in 2005 to that in 2006?
Your answer should be very brief. 1. What is the ratio of the Education completion rate(%) of Lesotho in 2005 to that in 2006?
Your answer should be very brief. 0.99. What is the ratio of the Education completion rate(%) of Myanmar in 2005 to that in 2006?
Provide a short and direct response. 0.92. What is the ratio of the Education completion rate(%) in Fragile and conflict affected situations in 2005 to that in 2007?
Give a very brief answer. 0.95. What is the ratio of the Education completion rate(%) of High income in 2005 to that in 2007?
Your response must be concise. 1. What is the ratio of the Education completion rate(%) in Lesotho in 2005 to that in 2007?
Your answer should be compact. 1.01. What is the ratio of the Education completion rate(%) in Myanmar in 2005 to that in 2007?
Provide a succinct answer. 0.93. What is the ratio of the Education completion rate(%) in Fragile and conflict affected situations in 2006 to that in 2007?
Offer a very short reply. 0.98. What is the ratio of the Education completion rate(%) of Myanmar in 2006 to that in 2007?
Offer a very short reply. 1.01. What is the difference between the highest and the second highest Education completion rate(%) of Fragile and conflict affected situations?
Offer a terse response. 0.67. What is the difference between the highest and the second highest Education completion rate(%) in High income?
Offer a very short reply. 0.3. What is the difference between the highest and the second highest Education completion rate(%) of Lesotho?
Your answer should be very brief. 0.45. What is the difference between the highest and the second highest Education completion rate(%) in Myanmar?
Make the answer very short. 0.34. What is the difference between the highest and the lowest Education completion rate(%) of Fragile and conflict affected situations?
Your answer should be compact. 5.8. What is the difference between the highest and the lowest Education completion rate(%) in High income?
Provide a short and direct response. 1.43. What is the difference between the highest and the lowest Education completion rate(%) in Lesotho?
Keep it short and to the point. 3.6. What is the difference between the highest and the lowest Education completion rate(%) in Myanmar?
Offer a terse response. 9.57. 